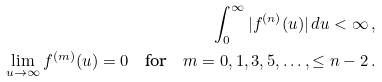Convert formula to latex. <formula><loc_0><loc_0><loc_500><loc_500>\int _ { 0 } ^ { \infty } | f ^ { ( n ) } ( u ) | \, d u < \infty \, , \\ \lim _ { u \to \infty } f ^ { ( m ) } ( u ) = 0 \quad \text {for} \quad m = 0 , 1 , 3 , 5 , \dots , \leq n - 2 \, .</formula> 